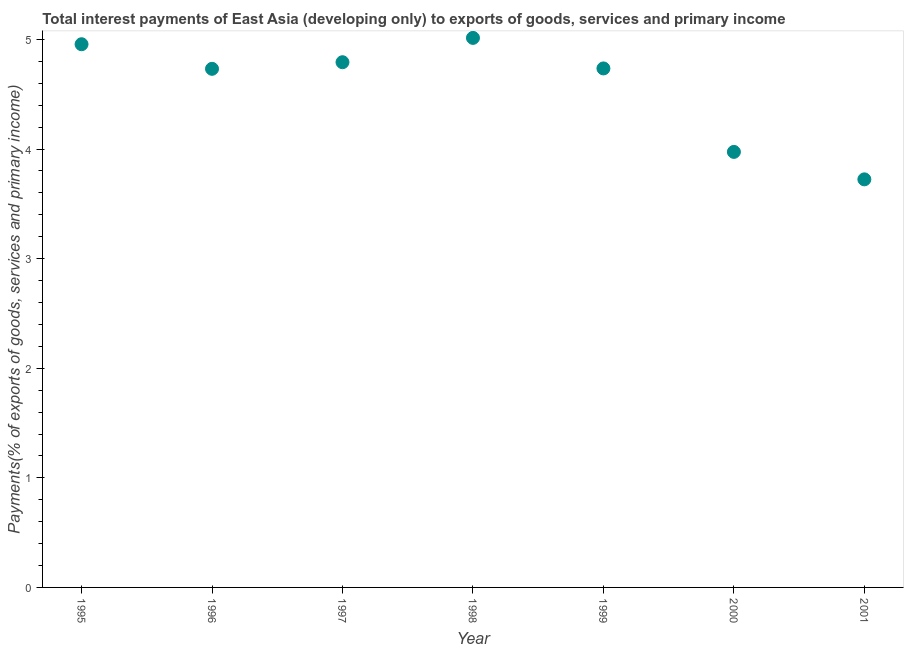What is the total interest payments on external debt in 1998?
Give a very brief answer. 5.01. Across all years, what is the maximum total interest payments on external debt?
Provide a short and direct response. 5.01. Across all years, what is the minimum total interest payments on external debt?
Your response must be concise. 3.72. What is the sum of the total interest payments on external debt?
Offer a terse response. 31.93. What is the difference between the total interest payments on external debt in 1995 and 1997?
Ensure brevity in your answer.  0.16. What is the average total interest payments on external debt per year?
Ensure brevity in your answer.  4.56. What is the median total interest payments on external debt?
Provide a short and direct response. 4.74. In how many years, is the total interest payments on external debt greater than 3 %?
Your answer should be very brief. 7. Do a majority of the years between 2000 and 2001 (inclusive) have total interest payments on external debt greater than 3 %?
Your answer should be very brief. Yes. What is the ratio of the total interest payments on external debt in 1998 to that in 2001?
Give a very brief answer. 1.35. Is the total interest payments on external debt in 1997 less than that in 2000?
Make the answer very short. No. What is the difference between the highest and the second highest total interest payments on external debt?
Your answer should be very brief. 0.06. What is the difference between the highest and the lowest total interest payments on external debt?
Your answer should be very brief. 1.29. In how many years, is the total interest payments on external debt greater than the average total interest payments on external debt taken over all years?
Offer a terse response. 5. How many dotlines are there?
Make the answer very short. 1. How many years are there in the graph?
Your answer should be very brief. 7. What is the difference between two consecutive major ticks on the Y-axis?
Your answer should be very brief. 1. Are the values on the major ticks of Y-axis written in scientific E-notation?
Make the answer very short. No. Does the graph contain any zero values?
Make the answer very short. No. What is the title of the graph?
Make the answer very short. Total interest payments of East Asia (developing only) to exports of goods, services and primary income. What is the label or title of the X-axis?
Offer a very short reply. Year. What is the label or title of the Y-axis?
Your answer should be very brief. Payments(% of exports of goods, services and primary income). What is the Payments(% of exports of goods, services and primary income) in 1995?
Keep it short and to the point. 4.96. What is the Payments(% of exports of goods, services and primary income) in 1996?
Your response must be concise. 4.73. What is the Payments(% of exports of goods, services and primary income) in 1997?
Your answer should be compact. 4.79. What is the Payments(% of exports of goods, services and primary income) in 1998?
Your answer should be compact. 5.01. What is the Payments(% of exports of goods, services and primary income) in 1999?
Make the answer very short. 4.74. What is the Payments(% of exports of goods, services and primary income) in 2000?
Ensure brevity in your answer.  3.97. What is the Payments(% of exports of goods, services and primary income) in 2001?
Your answer should be compact. 3.72. What is the difference between the Payments(% of exports of goods, services and primary income) in 1995 and 1996?
Offer a terse response. 0.22. What is the difference between the Payments(% of exports of goods, services and primary income) in 1995 and 1997?
Make the answer very short. 0.16. What is the difference between the Payments(% of exports of goods, services and primary income) in 1995 and 1998?
Provide a short and direct response. -0.06. What is the difference between the Payments(% of exports of goods, services and primary income) in 1995 and 1999?
Make the answer very short. 0.22. What is the difference between the Payments(% of exports of goods, services and primary income) in 1995 and 2000?
Provide a short and direct response. 0.98. What is the difference between the Payments(% of exports of goods, services and primary income) in 1995 and 2001?
Keep it short and to the point. 1.23. What is the difference between the Payments(% of exports of goods, services and primary income) in 1996 and 1997?
Make the answer very short. -0.06. What is the difference between the Payments(% of exports of goods, services and primary income) in 1996 and 1998?
Keep it short and to the point. -0.28. What is the difference between the Payments(% of exports of goods, services and primary income) in 1996 and 1999?
Give a very brief answer. -0. What is the difference between the Payments(% of exports of goods, services and primary income) in 1996 and 2000?
Ensure brevity in your answer.  0.76. What is the difference between the Payments(% of exports of goods, services and primary income) in 1996 and 2001?
Offer a terse response. 1.01. What is the difference between the Payments(% of exports of goods, services and primary income) in 1997 and 1998?
Make the answer very short. -0.22. What is the difference between the Payments(% of exports of goods, services and primary income) in 1997 and 1999?
Your response must be concise. 0.06. What is the difference between the Payments(% of exports of goods, services and primary income) in 1997 and 2000?
Offer a very short reply. 0.82. What is the difference between the Payments(% of exports of goods, services and primary income) in 1997 and 2001?
Keep it short and to the point. 1.07. What is the difference between the Payments(% of exports of goods, services and primary income) in 1998 and 1999?
Give a very brief answer. 0.28. What is the difference between the Payments(% of exports of goods, services and primary income) in 1998 and 2000?
Ensure brevity in your answer.  1.04. What is the difference between the Payments(% of exports of goods, services and primary income) in 1998 and 2001?
Your answer should be compact. 1.29. What is the difference between the Payments(% of exports of goods, services and primary income) in 1999 and 2000?
Provide a succinct answer. 0.76. What is the difference between the Payments(% of exports of goods, services and primary income) in 1999 and 2001?
Give a very brief answer. 1.01. What is the difference between the Payments(% of exports of goods, services and primary income) in 2000 and 2001?
Your response must be concise. 0.25. What is the ratio of the Payments(% of exports of goods, services and primary income) in 1995 to that in 1996?
Offer a terse response. 1.05. What is the ratio of the Payments(% of exports of goods, services and primary income) in 1995 to that in 1997?
Give a very brief answer. 1.03. What is the ratio of the Payments(% of exports of goods, services and primary income) in 1995 to that in 1998?
Keep it short and to the point. 0.99. What is the ratio of the Payments(% of exports of goods, services and primary income) in 1995 to that in 1999?
Your answer should be compact. 1.05. What is the ratio of the Payments(% of exports of goods, services and primary income) in 1995 to that in 2000?
Your answer should be compact. 1.25. What is the ratio of the Payments(% of exports of goods, services and primary income) in 1995 to that in 2001?
Make the answer very short. 1.33. What is the ratio of the Payments(% of exports of goods, services and primary income) in 1996 to that in 1997?
Offer a very short reply. 0.99. What is the ratio of the Payments(% of exports of goods, services and primary income) in 1996 to that in 1998?
Provide a succinct answer. 0.94. What is the ratio of the Payments(% of exports of goods, services and primary income) in 1996 to that in 2000?
Give a very brief answer. 1.19. What is the ratio of the Payments(% of exports of goods, services and primary income) in 1996 to that in 2001?
Make the answer very short. 1.27. What is the ratio of the Payments(% of exports of goods, services and primary income) in 1997 to that in 1998?
Your answer should be compact. 0.96. What is the ratio of the Payments(% of exports of goods, services and primary income) in 1997 to that in 2000?
Provide a short and direct response. 1.21. What is the ratio of the Payments(% of exports of goods, services and primary income) in 1997 to that in 2001?
Keep it short and to the point. 1.29. What is the ratio of the Payments(% of exports of goods, services and primary income) in 1998 to that in 1999?
Make the answer very short. 1.06. What is the ratio of the Payments(% of exports of goods, services and primary income) in 1998 to that in 2000?
Keep it short and to the point. 1.26. What is the ratio of the Payments(% of exports of goods, services and primary income) in 1998 to that in 2001?
Make the answer very short. 1.35. What is the ratio of the Payments(% of exports of goods, services and primary income) in 1999 to that in 2000?
Ensure brevity in your answer.  1.19. What is the ratio of the Payments(% of exports of goods, services and primary income) in 1999 to that in 2001?
Offer a very short reply. 1.27. What is the ratio of the Payments(% of exports of goods, services and primary income) in 2000 to that in 2001?
Give a very brief answer. 1.07. 